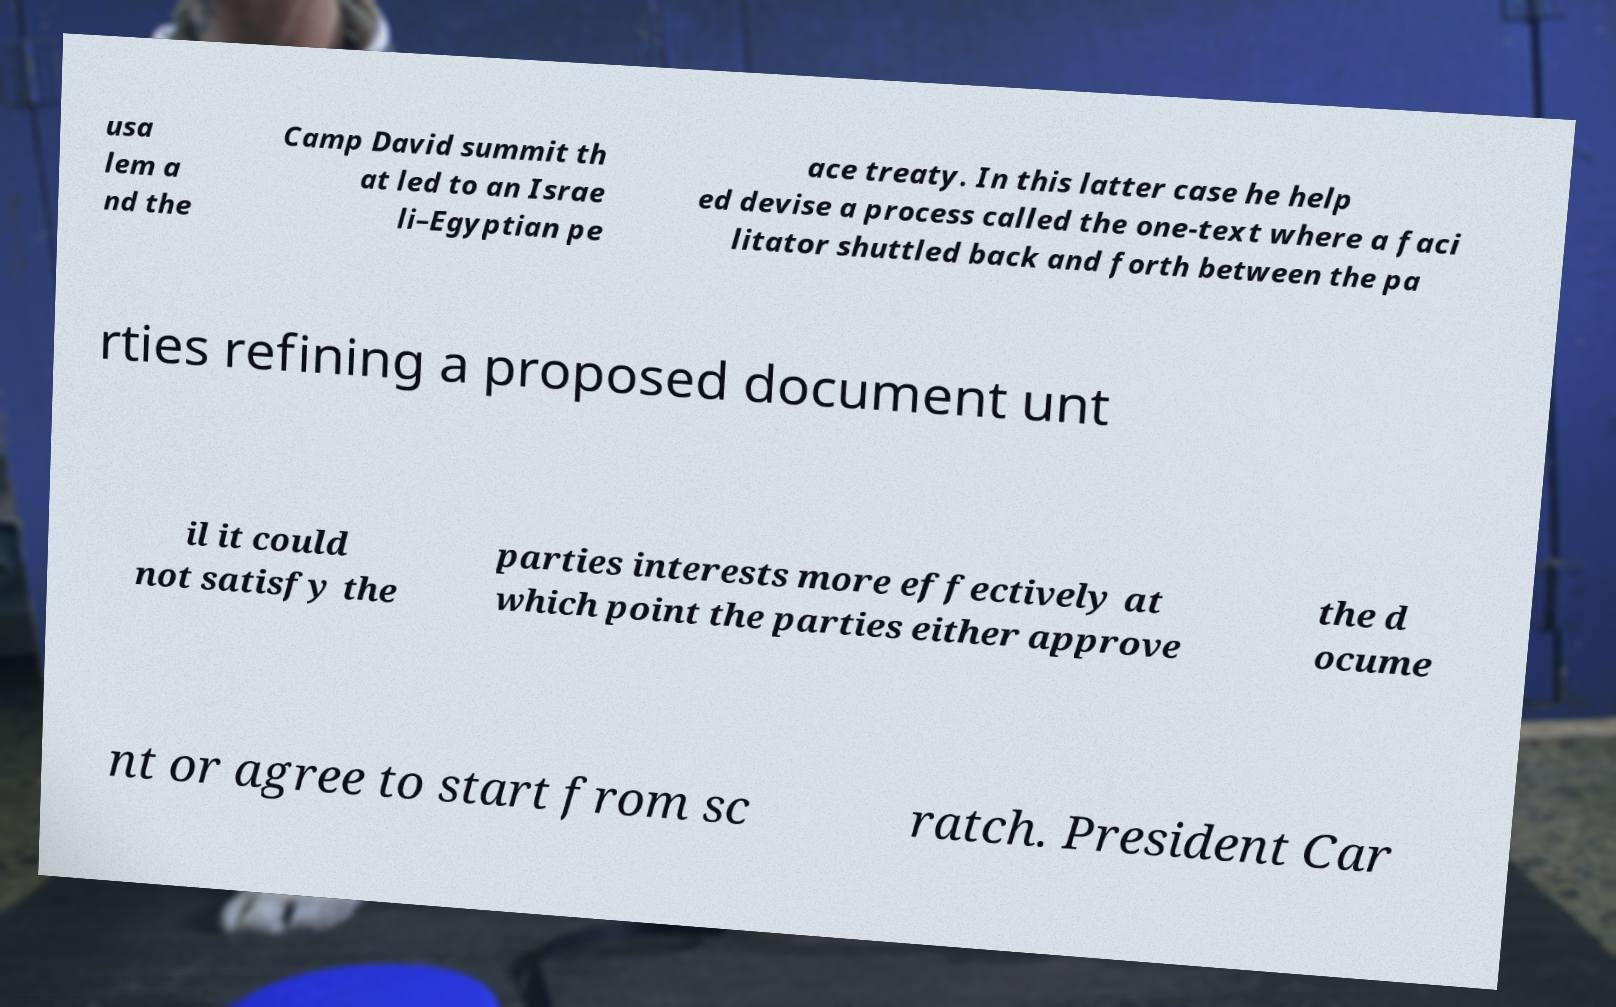I need the written content from this picture converted into text. Can you do that? usa lem a nd the Camp David summit th at led to an Israe li–Egyptian pe ace treaty. In this latter case he help ed devise a process called the one-text where a faci litator shuttled back and forth between the pa rties refining a proposed document unt il it could not satisfy the parties interests more effectively at which point the parties either approve the d ocume nt or agree to start from sc ratch. President Car 